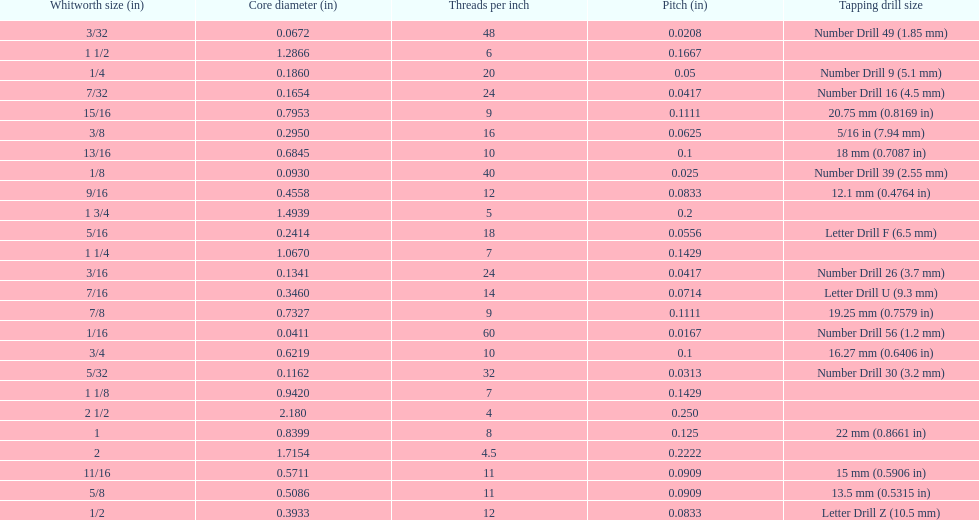Which whitworth size has the same number of threads per inch as 3/16? 7/32. Help me parse the entirety of this table. {'header': ['Whitworth size (in)', 'Core diameter (in)', 'Threads per\xa0inch', 'Pitch (in)', 'Tapping drill size'], 'rows': [['3/32', '0.0672', '48', '0.0208', 'Number Drill 49 (1.85\xa0mm)'], ['1 1/2', '1.2866', '6', '0.1667', ''], ['1/4', '0.1860', '20', '0.05', 'Number Drill 9 (5.1\xa0mm)'], ['7/32', '0.1654', '24', '0.0417', 'Number Drill 16 (4.5\xa0mm)'], ['15/16', '0.7953', '9', '0.1111', '20.75\xa0mm (0.8169\xa0in)'], ['3/8', '0.2950', '16', '0.0625', '5/16\xa0in (7.94\xa0mm)'], ['13/16', '0.6845', '10', '0.1', '18\xa0mm (0.7087\xa0in)'], ['1/8', '0.0930', '40', '0.025', 'Number Drill 39 (2.55\xa0mm)'], ['9/16', '0.4558', '12', '0.0833', '12.1\xa0mm (0.4764\xa0in)'], ['1 3/4', '1.4939', '5', '0.2', ''], ['5/16', '0.2414', '18', '0.0556', 'Letter Drill F (6.5\xa0mm)'], ['1 1/4', '1.0670', '7', '0.1429', ''], ['3/16', '0.1341', '24', '0.0417', 'Number Drill 26 (3.7\xa0mm)'], ['7/16', '0.3460', '14', '0.0714', 'Letter Drill U (9.3\xa0mm)'], ['7/8', '0.7327', '9', '0.1111', '19.25\xa0mm (0.7579\xa0in)'], ['1/16', '0.0411', '60', '0.0167', 'Number Drill 56 (1.2\xa0mm)'], ['3/4', '0.6219', '10', '0.1', '16.27\xa0mm (0.6406\xa0in)'], ['5/32', '0.1162', '32', '0.0313', 'Number Drill 30 (3.2\xa0mm)'], ['1 1/8', '0.9420', '7', '0.1429', ''], ['2 1/2', '2.180', '4', '0.250', ''], ['1', '0.8399', '8', '0.125', '22\xa0mm (0.8661\xa0in)'], ['2', '1.7154', '4.5', '0.2222', ''], ['11/16', '0.5711', '11', '0.0909', '15\xa0mm (0.5906\xa0in)'], ['5/8', '0.5086', '11', '0.0909', '13.5\xa0mm (0.5315\xa0in)'], ['1/2', '0.3933', '12', '0.0833', 'Letter Drill Z (10.5\xa0mm)']]} 